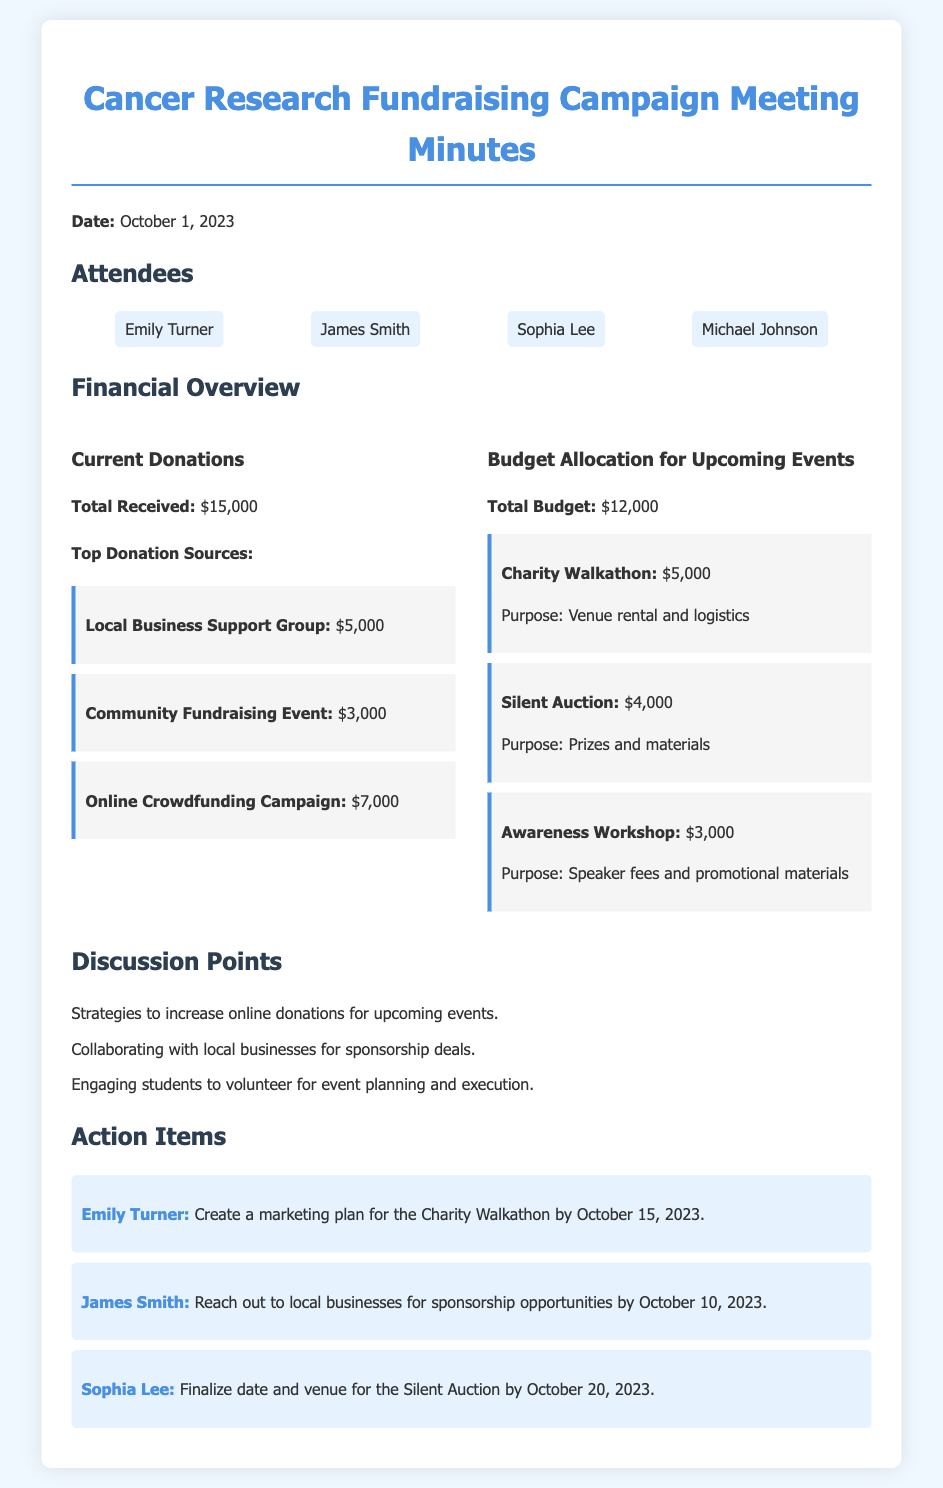What is the date of the meeting? The date of the meeting is stated at the beginning of the document as October 1, 2023.
Answer: October 1, 2023 What is the total amount of current donations received? The document provides the total donations in the section titled 'Current Donations', which is $15,000.
Answer: $15,000 Who donated the largest amount? The largest donation source is indicated as the 'Local Business Support Group', contributing $5,000.
Answer: Local Business Support Group What is the total budget for upcoming events? The total budget is shown in the 'Budget Allocation' section as $12,000.
Answer: $12,000 How much is allocated for the Charity Walkathon? The budget item for the Charity Walkathon is specified as $5,000 within the budget allocation section.
Answer: $5,000 Which action item is assigned to Emily Turner? Emily Turner's action item is detailed as creating a marketing plan for the Charity Walkathon by October 15, 2023.
Answer: Create a marketing plan for the Charity Walkathon by October 15, 2023 What is one strategy discussed to increase donations? One discussion point mentioned strategies for increasing online donations for upcoming events.
Answer: Increasing online donations How many events are listed in the budget allocation? The budget allocation lists three events: the Charity Walkathon, Silent Auction, and Awareness Workshop.
Answer: Three events What is the purpose of the Silent Auction in the budget? The purpose of the Silent Auction is specified as funding for prizes and materials.
Answer: Prizes and materials 